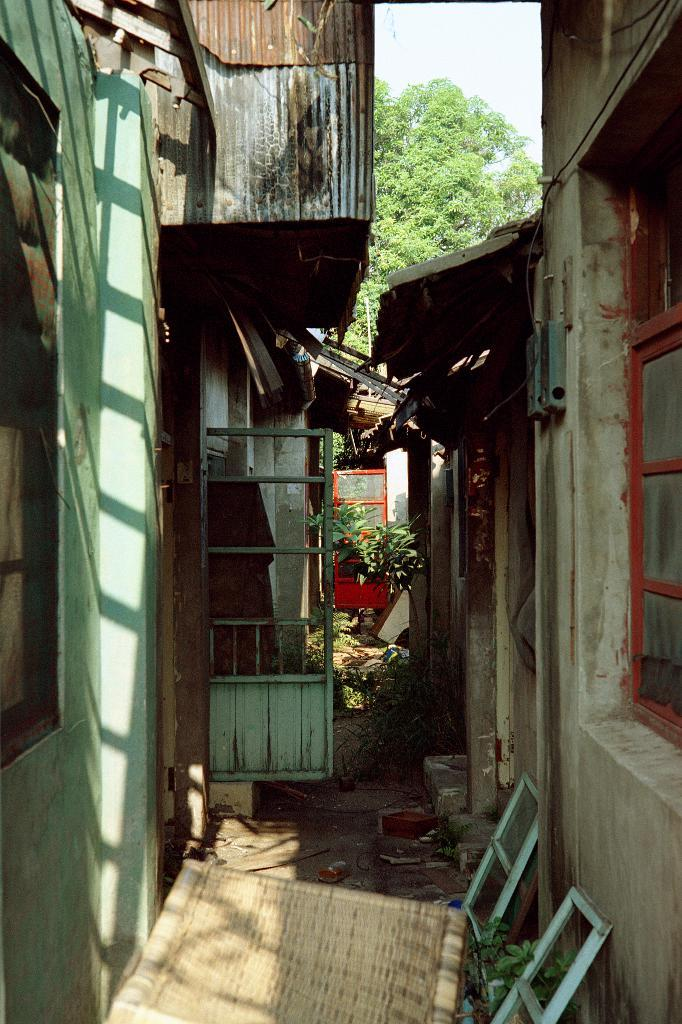What type of structures are visible in the image? There are houses with windows and doors in the image. What other elements can be seen in the image besides the houses? There are plants and wooden objects visible in the image. What can be seen in the background of the image? There are trees and the sky visible in the background of the image. How many family members are sitting at the table in the image? There is no table or family members present in the image. What type of slip can be seen on the floor in the image? There is no slip visible on the floor in the image. 